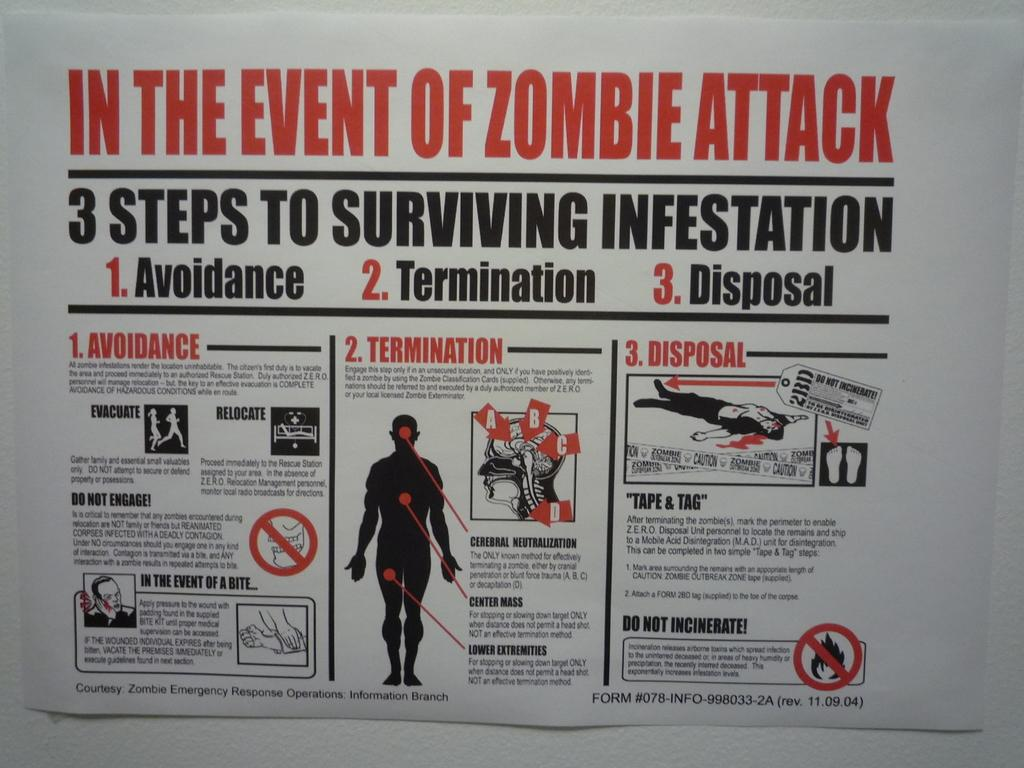Provide a one-sentence caption for the provided image. Guide showing what to do in case of a Zombie Attack. 